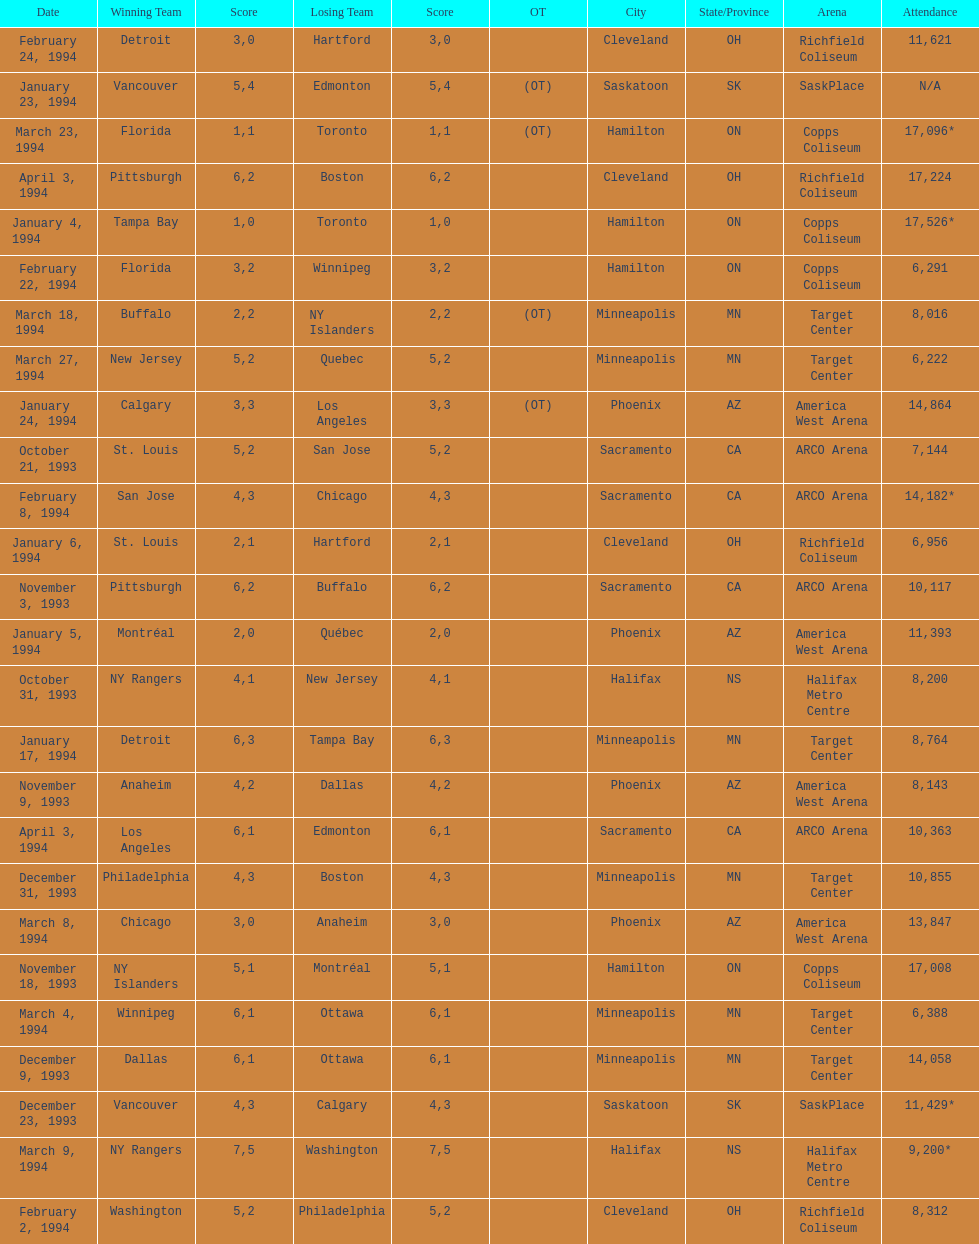The game with the most attendees took place on which date? January 4, 1994. 